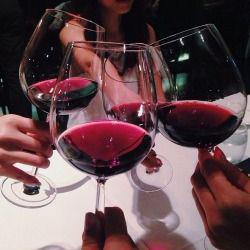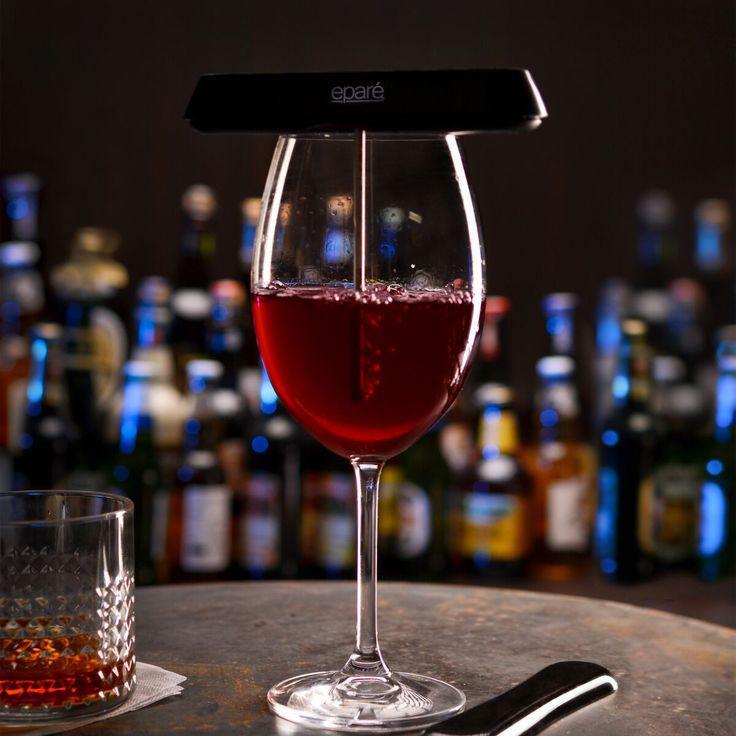The first image is the image on the left, the second image is the image on the right. For the images shown, is this caption "Exactly one image shows hands holding stemmed glasses of wine." true? Answer yes or no. Yes. The first image is the image on the left, the second image is the image on the right. For the images displayed, is the sentence "There are human hands holding a glass of wine." factually correct? Answer yes or no. Yes. 